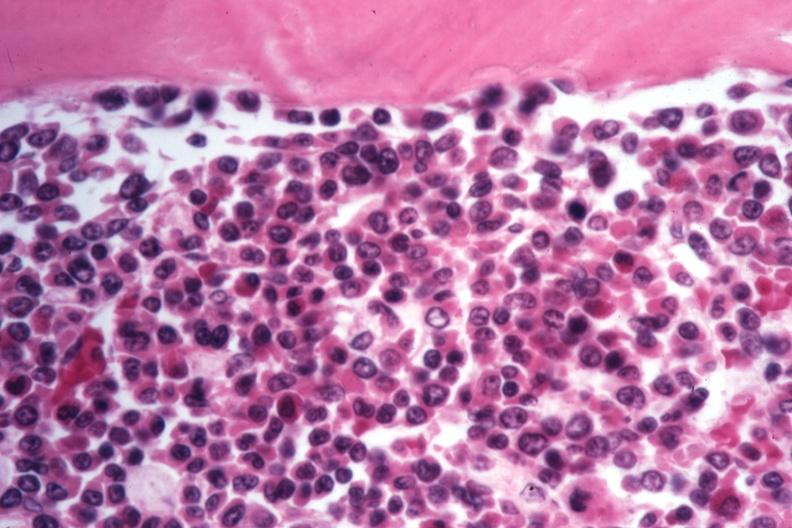s bone marrow present?
Answer the question using a single word or phrase. Yes 